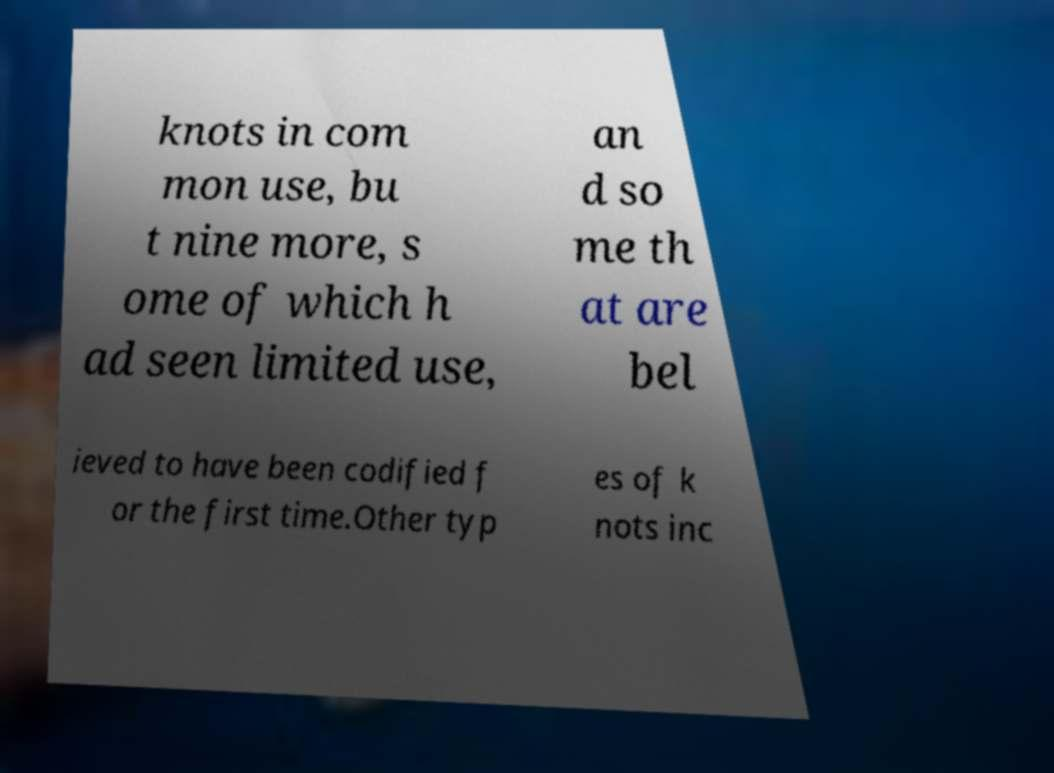Can you accurately transcribe the text from the provided image for me? knots in com mon use, bu t nine more, s ome of which h ad seen limited use, an d so me th at are bel ieved to have been codified f or the first time.Other typ es of k nots inc 